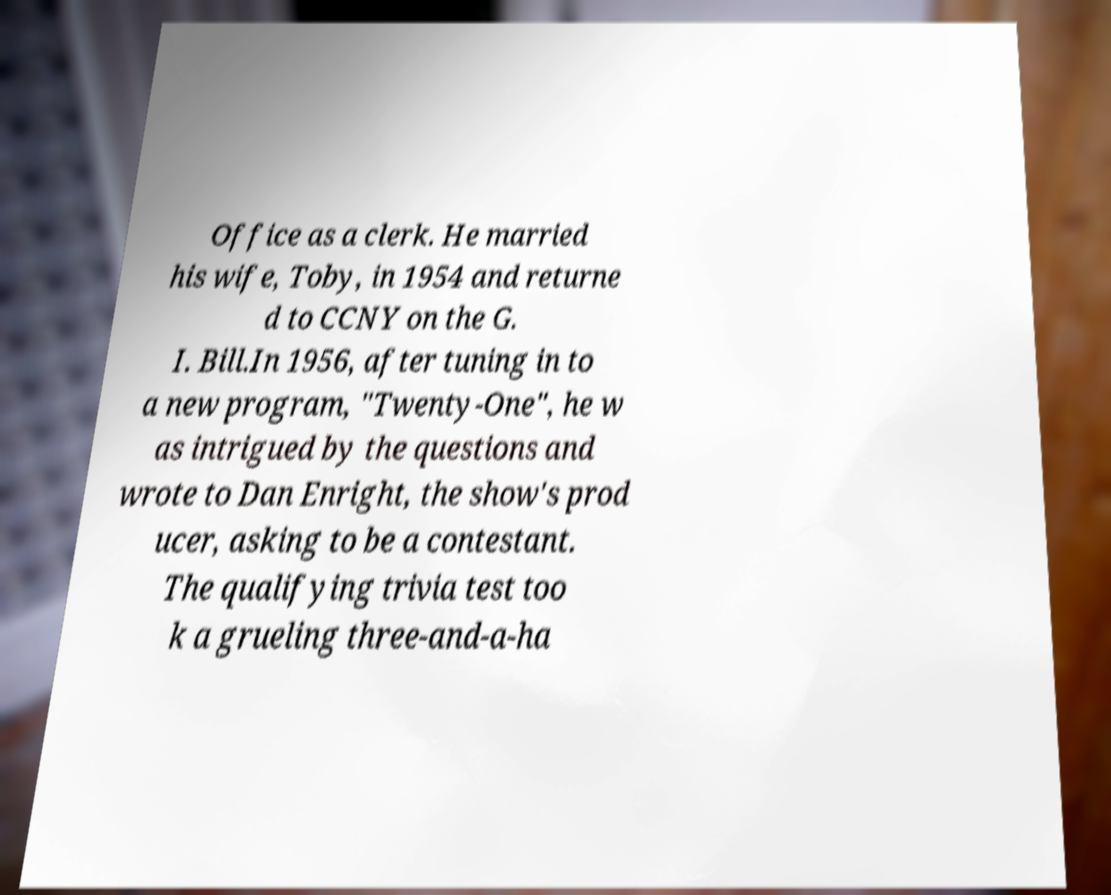Can you accurately transcribe the text from the provided image for me? Office as a clerk. He married his wife, Toby, in 1954 and returne d to CCNY on the G. I. Bill.In 1956, after tuning in to a new program, "Twenty-One", he w as intrigued by the questions and wrote to Dan Enright, the show's prod ucer, asking to be a contestant. The qualifying trivia test too k a grueling three-and-a-ha 